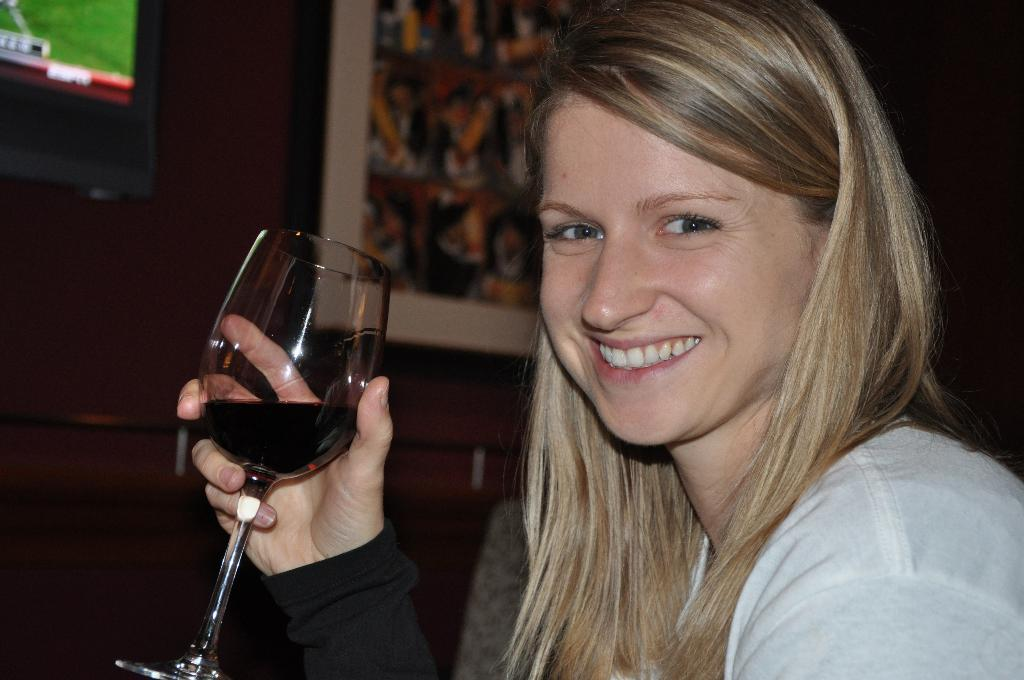Who is present in the image? There is a woman in the image. What is the woman holding in her hand? The woman is holding a glass in her hand. What is the woman's facial expression? The woman is smiling. What can be seen in the background of the image? There is a wall in the background of the image. What other objects are visible in the image? There is a screen and a frame in the image. What type of statement does the bat make in the image? There is no bat present in the image, so it is not possible to answer that question. 